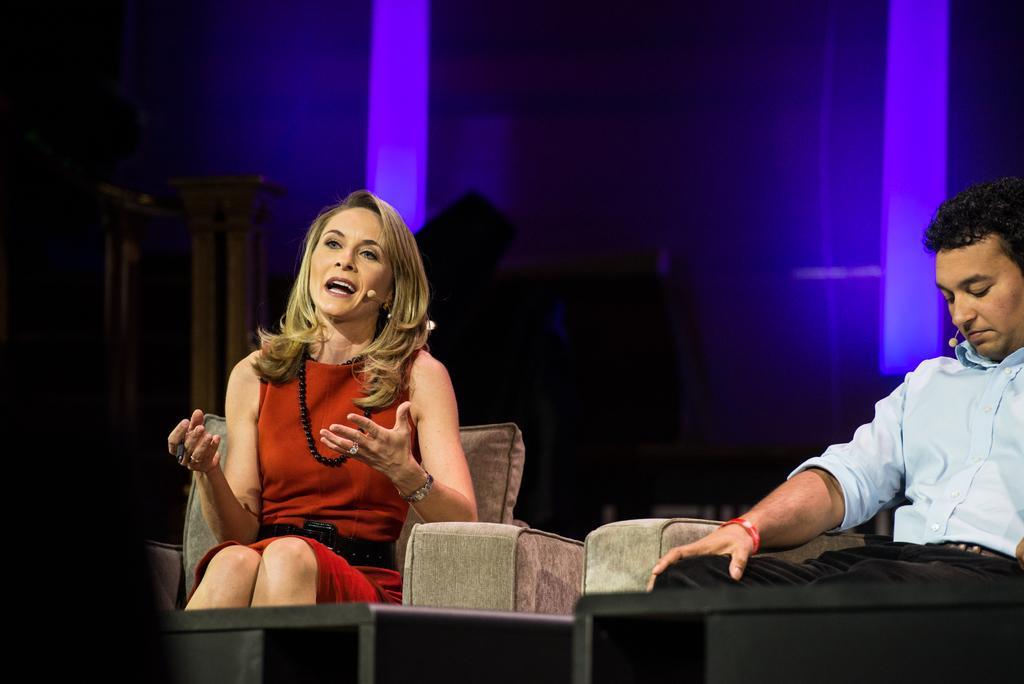Can you describe this image briefly? In the image there are two people sitting on sofas and the woman who is sitting on the first sofa is speaking something, behind them there are some lights and other settings. 